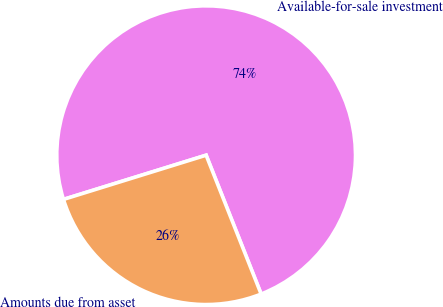Convert chart. <chart><loc_0><loc_0><loc_500><loc_500><pie_chart><fcel>Available-for-sale investment<fcel>Amounts due from asset<nl><fcel>73.78%<fcel>26.22%<nl></chart> 